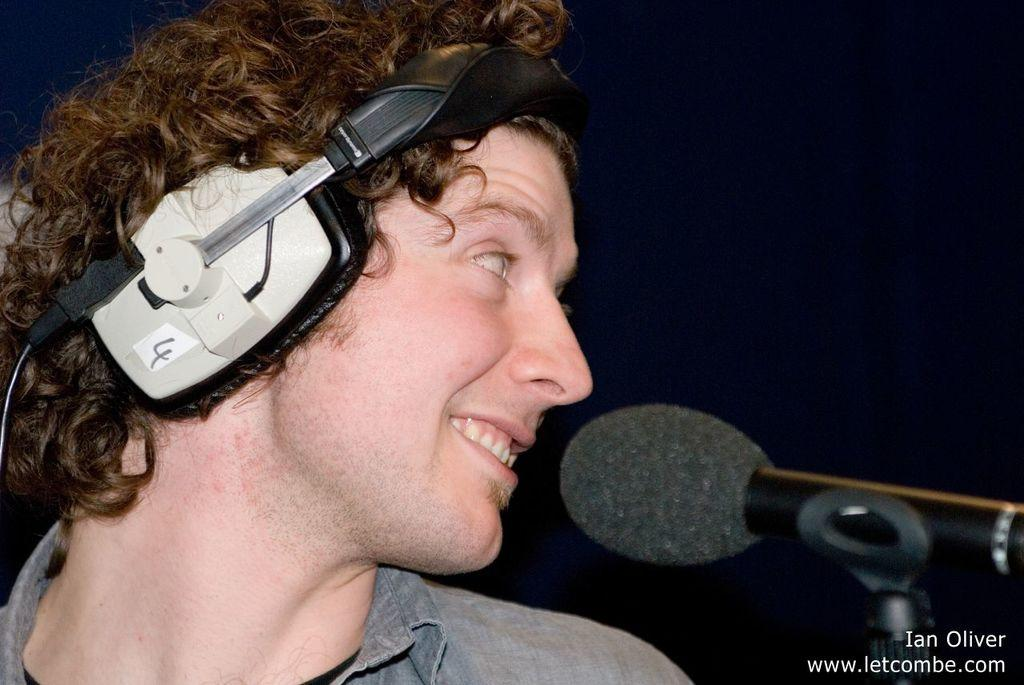Who is present in the image? There is a man in the image. What is the man doing in the image? The man is turning to the left hand side and smiling. What is the man wearing in the image? The man is wearing a headset. What equipment is present in front of the man? There is a microphone on a stand in front of the man. How many owls are sitting on the man's neck in the image? There are no owls present in the image, let alone on the man's neck. What type of rabbits can be seen hopping around the man in the image? There are no rabbits present in the image; the man is the only person visible. 